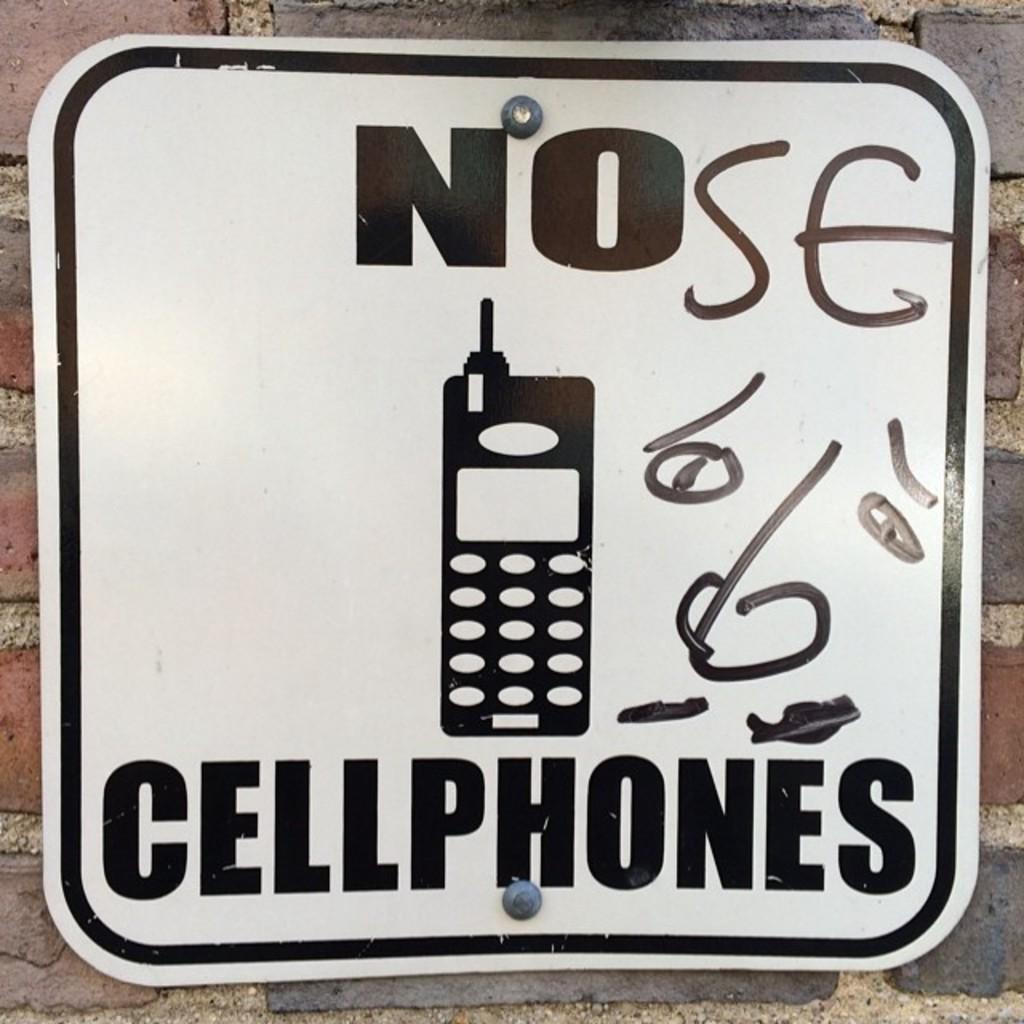Can i use a cellphone?
Offer a terse response. No. How does the graffiti alter the way people read the sign?
Your response must be concise. Nose. 